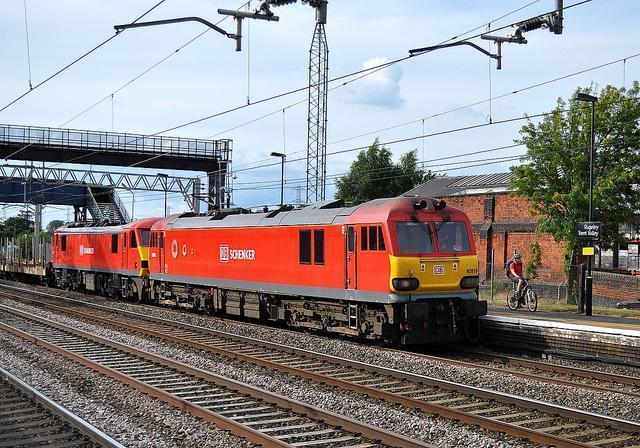Why has the cyclist covered his head?
Make your selection from the four choices given to correctly answer the question.
Options: Safety, fashion, warmth, religion. Safety. 